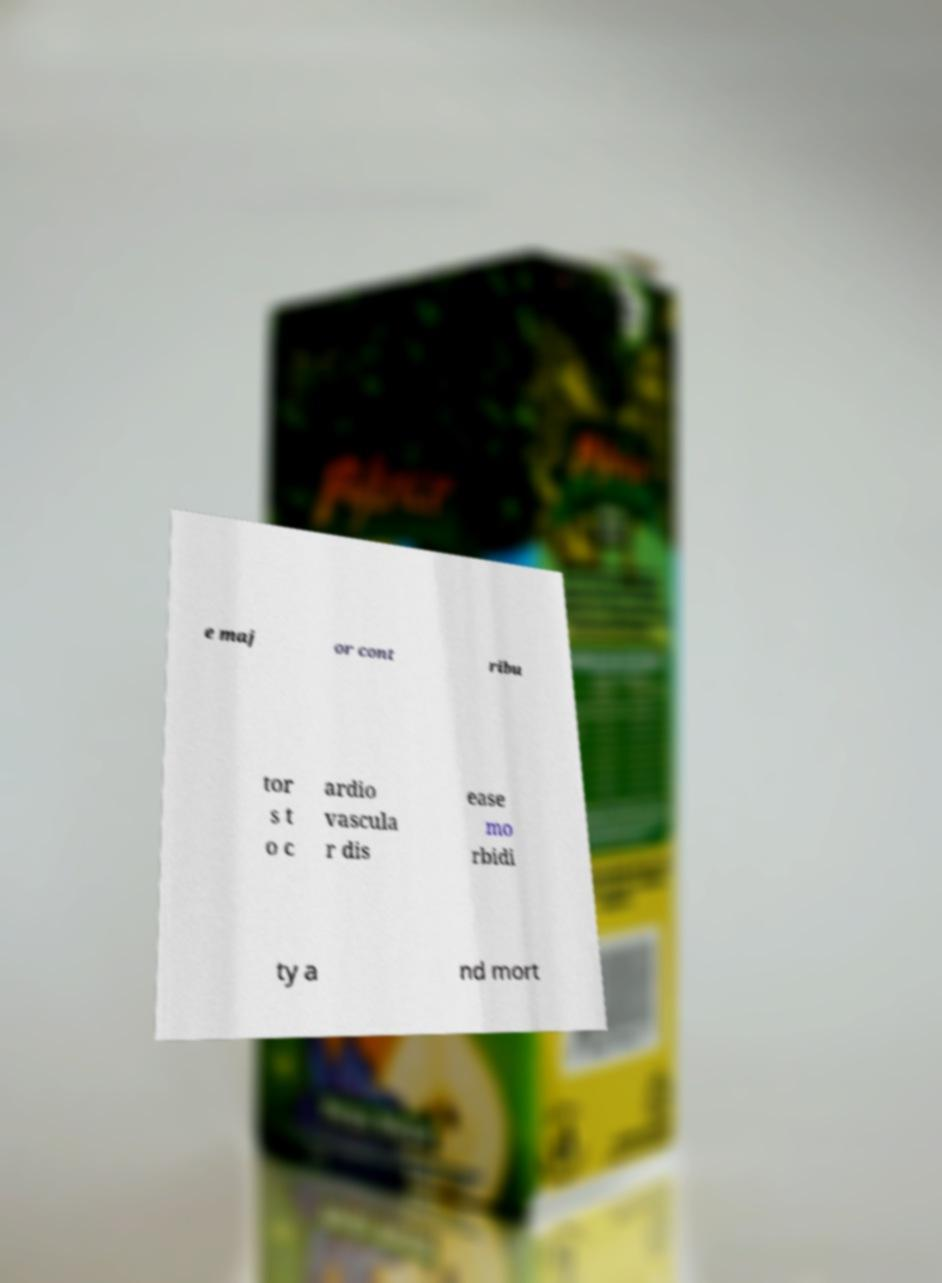Please identify and transcribe the text found in this image. e maj or cont ribu tor s t o c ardio vascula r dis ease mo rbidi ty a nd mort 